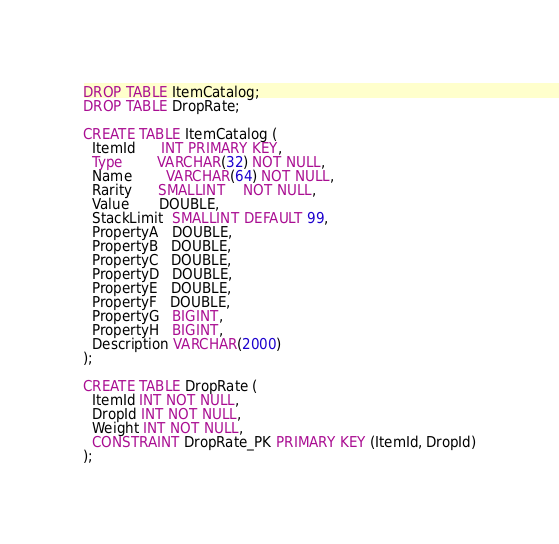<code> <loc_0><loc_0><loc_500><loc_500><_SQL_>DROP TABLE ItemCatalog;
DROP TABLE DropRate;

CREATE TABLE ItemCatalog (
  ItemId      INT PRIMARY KEY,
  Type        VARCHAR(32) NOT NULL,
  Name        VARCHAR(64) NOT NULL,
  Rarity      SMALLINT    NOT NULL,
  Value       DOUBLE,
  StackLimit  SMALLINT DEFAULT 99,
  PropertyA   DOUBLE,
  PropertyB   DOUBLE,
  PropertyC   DOUBLE,
  PropertyD   DOUBLE,
  PropertyE   DOUBLE,
  PropertyF   DOUBLE,
  PropertyG   BIGINT,
  PropertyH   BIGINT,
  Description VARCHAR(2000)
);

CREATE TABLE DropRate (
  ItemId INT NOT NULL,
  DropId INT NOT NULL,
  Weight INT NOT NULL,
  CONSTRAINT DropRate_PK PRIMARY KEY (ItemId, DropId)
);</code> 